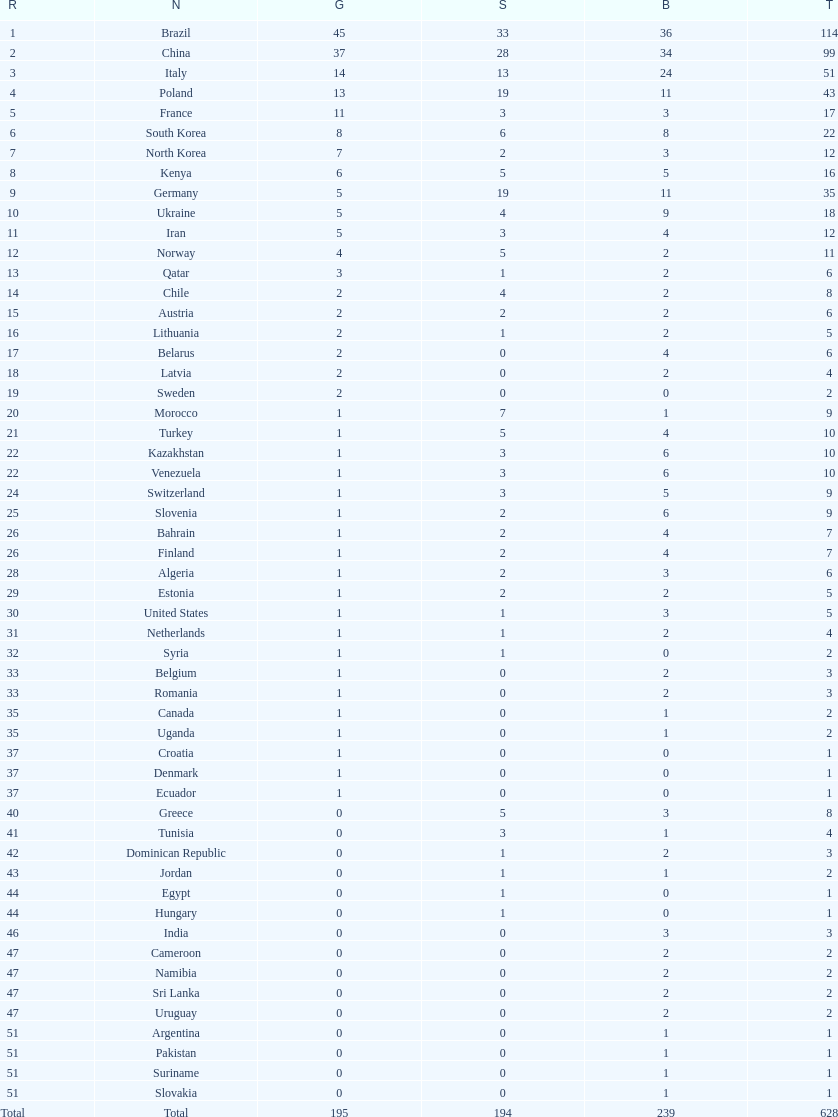How many total medals did norway win? 11. 